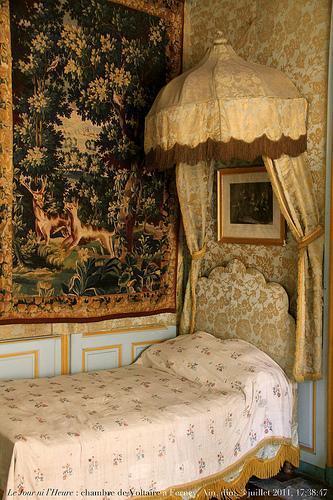How many deer are shown?
Give a very brief answer. 2. 